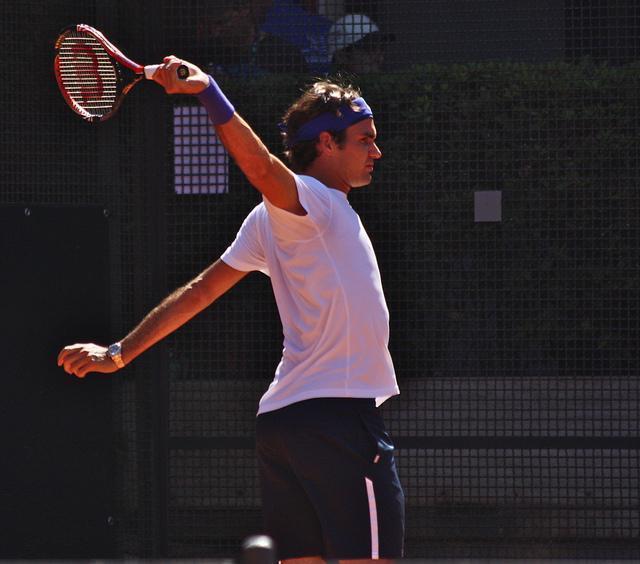What is the silver object on the man's wrist used for?
Answer the question by selecting the correct answer among the 4 following choices.
Options: Telling time, covering cut, preventing sweat, tracking steps. Telling time. 